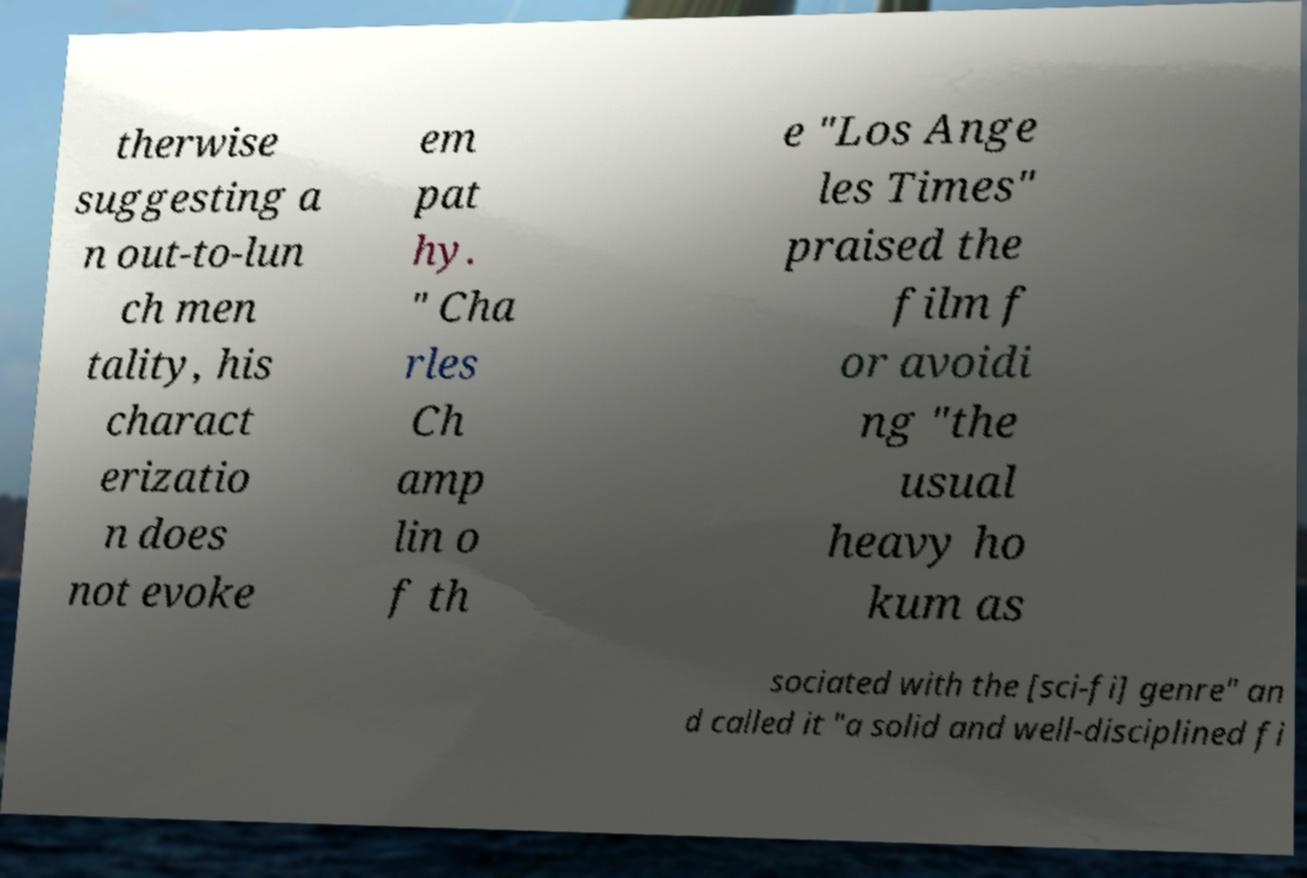Could you assist in decoding the text presented in this image and type it out clearly? therwise suggesting a n out-to-lun ch men tality, his charact erizatio n does not evoke em pat hy. " Cha rles Ch amp lin o f th e "Los Ange les Times" praised the film f or avoidi ng "the usual heavy ho kum as sociated with the [sci-fi] genre" an d called it "a solid and well-disciplined fi 